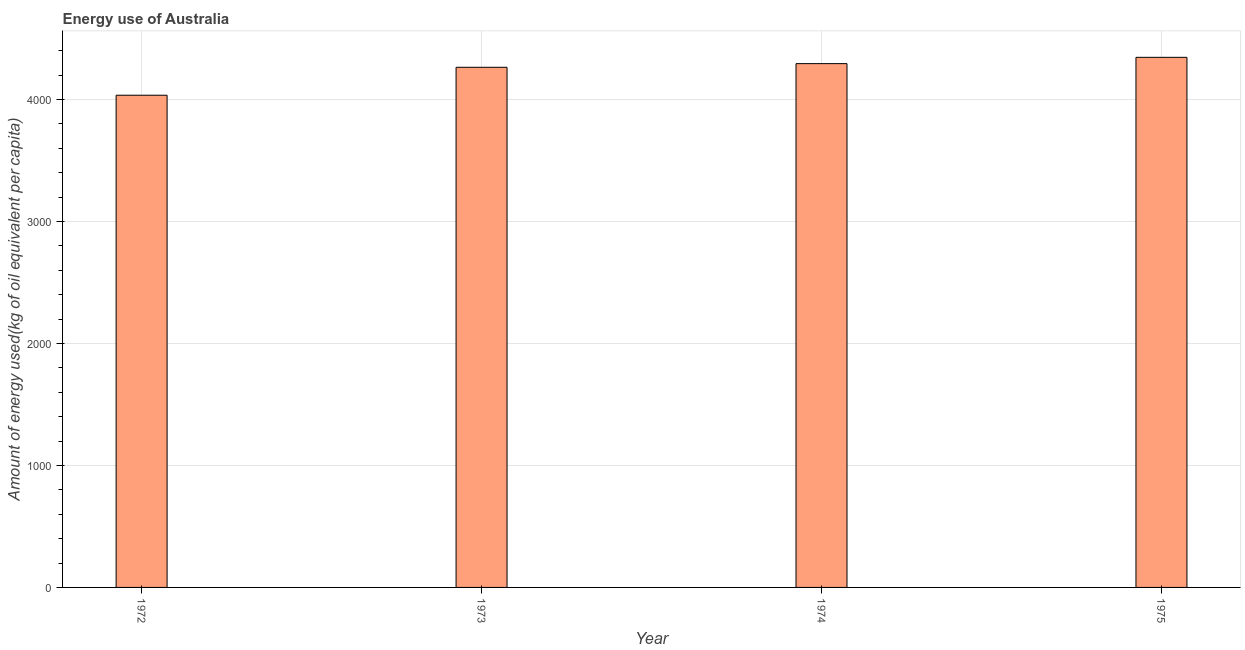Does the graph contain grids?
Offer a very short reply. Yes. What is the title of the graph?
Give a very brief answer. Energy use of Australia. What is the label or title of the Y-axis?
Make the answer very short. Amount of energy used(kg of oil equivalent per capita). What is the amount of energy used in 1974?
Your answer should be compact. 4294.16. Across all years, what is the maximum amount of energy used?
Your answer should be compact. 4345.87. Across all years, what is the minimum amount of energy used?
Provide a short and direct response. 4035.21. In which year was the amount of energy used maximum?
Your answer should be compact. 1975. In which year was the amount of energy used minimum?
Offer a very short reply. 1972. What is the sum of the amount of energy used?
Your answer should be compact. 1.69e+04. What is the difference between the amount of energy used in 1973 and 1974?
Give a very brief answer. -29.89. What is the average amount of energy used per year?
Provide a succinct answer. 4234.88. What is the median amount of energy used?
Your answer should be compact. 4279.22. What is the ratio of the amount of energy used in 1972 to that in 1975?
Keep it short and to the point. 0.93. What is the difference between the highest and the second highest amount of energy used?
Offer a terse response. 51.71. Is the sum of the amount of energy used in 1972 and 1973 greater than the maximum amount of energy used across all years?
Provide a succinct answer. Yes. What is the difference between the highest and the lowest amount of energy used?
Your answer should be very brief. 310.67. How many bars are there?
Provide a short and direct response. 4. Are all the bars in the graph horizontal?
Ensure brevity in your answer.  No. What is the difference between two consecutive major ticks on the Y-axis?
Provide a short and direct response. 1000. What is the Amount of energy used(kg of oil equivalent per capita) in 1972?
Your answer should be compact. 4035.21. What is the Amount of energy used(kg of oil equivalent per capita) of 1973?
Your answer should be very brief. 4264.27. What is the Amount of energy used(kg of oil equivalent per capita) in 1974?
Ensure brevity in your answer.  4294.16. What is the Amount of energy used(kg of oil equivalent per capita) in 1975?
Your response must be concise. 4345.87. What is the difference between the Amount of energy used(kg of oil equivalent per capita) in 1972 and 1973?
Your answer should be compact. -229.06. What is the difference between the Amount of energy used(kg of oil equivalent per capita) in 1972 and 1974?
Your answer should be compact. -258.96. What is the difference between the Amount of energy used(kg of oil equivalent per capita) in 1972 and 1975?
Ensure brevity in your answer.  -310.67. What is the difference between the Amount of energy used(kg of oil equivalent per capita) in 1973 and 1974?
Provide a short and direct response. -29.89. What is the difference between the Amount of energy used(kg of oil equivalent per capita) in 1973 and 1975?
Your response must be concise. -81.6. What is the difference between the Amount of energy used(kg of oil equivalent per capita) in 1974 and 1975?
Give a very brief answer. -51.71. What is the ratio of the Amount of energy used(kg of oil equivalent per capita) in 1972 to that in 1973?
Keep it short and to the point. 0.95. What is the ratio of the Amount of energy used(kg of oil equivalent per capita) in 1972 to that in 1974?
Provide a short and direct response. 0.94. What is the ratio of the Amount of energy used(kg of oil equivalent per capita) in 1972 to that in 1975?
Make the answer very short. 0.93. What is the ratio of the Amount of energy used(kg of oil equivalent per capita) in 1973 to that in 1975?
Keep it short and to the point. 0.98. 